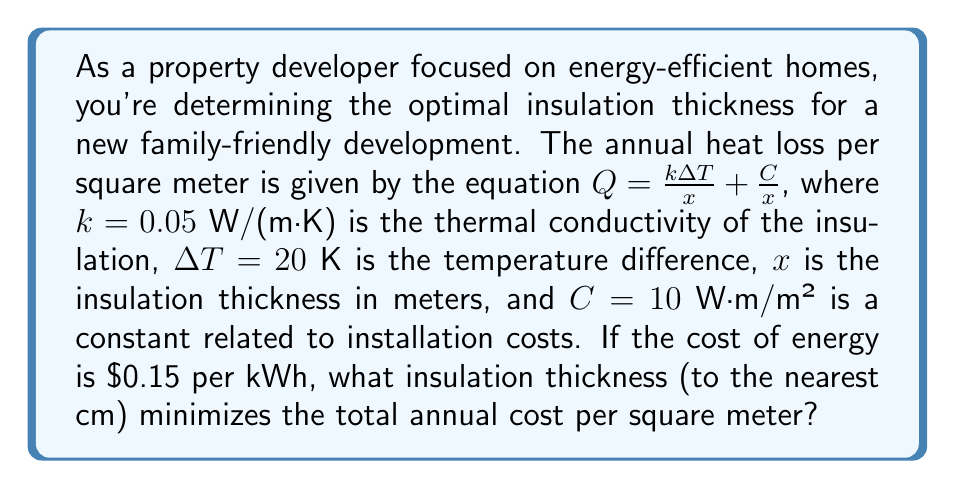Can you solve this math problem? To find the optimal insulation thickness, we need to minimize the total annual cost, which is the sum of the energy cost and the insulation cost. Let's approach this step-by-step:

1) The annual heat loss $Q$ is given in W/m². To convert this to kWh/m²/year, we multiply by the number of hours in a year:

   Annual energy loss = $Q \cdot 24 \cdot 365 / 1000$ kWh/m²/year

2) The annual energy cost per square meter is:

   Energy cost = $0.15 \cdot Q \cdot 24 \cdot 365 / 1000$ $/m²/year

3) Substituting the given equation for $Q$:

   Energy cost = $0.15 \cdot (\frac{0.05 \cdot 20}{x} + \frac{10}{x}) \cdot 24 \cdot 365 / 1000$ $/m²/year

4) Simplifying:

   Energy cost = $\frac{0.788}{x}$ $/m²/year

5) The insulation cost is represented by $\frac{C}{x}$ in the original equation. Converting this to an annual cost:

   Insulation cost = $\frac{10}{x} \cdot 0.15 \cdot 24 \cdot 365 / 1000 = \frac{0.1314}{x}$ $/m²/year

6) The total annual cost $T$ is the sum of these:

   $T = \frac{0.788}{x} + \frac{0.1314}{x} = \frac{0.9194}{x}$ $/m²/year

7) To find the minimum, we differentiate $T$ with respect to $x$ and set it to zero:

   $\frac{dT}{dx} = -\frac{0.9194}{x^2} = 0$

8) This equation is satisfied when $x$ approaches infinity, but we need a practical solution. The second derivative $\frac{d^2T}{dx^2} = \frac{1.8388}{x^3}$ is always positive for positive $x$, confirming a minimum.

9) In practice, the optimal thickness occurs when the marginal cost of adding insulation equals the marginal benefit. This happens when the energy cost equals the insulation cost:

   $\frac{0.788}{x} = \frac{0.1314}{x}$

10) Solving for $x$:

    $x = \sqrt{\frac{0.9194}{0.1314}} = 2.64$ m

11) Rounding to the nearest cm:

    $x = 264$ cm
Answer: 264 cm 